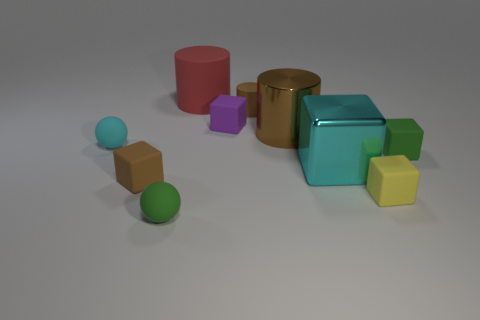Subtract all large cylinders. How many cylinders are left? 1 Subtract all brown blocks. How many blocks are left? 4 Subtract 2 blocks. How many blocks are left? 3 Subtract all gray balls. Subtract all purple cylinders. How many balls are left? 2 Subtract all gray cylinders. How many red blocks are left? 0 Subtract all small things. Subtract all red things. How many objects are left? 2 Add 7 small cyan objects. How many small cyan objects are left? 8 Add 1 large gray shiny cylinders. How many large gray shiny cylinders exist? 1 Subtract 0 yellow cylinders. How many objects are left? 10 Subtract all cylinders. How many objects are left? 7 